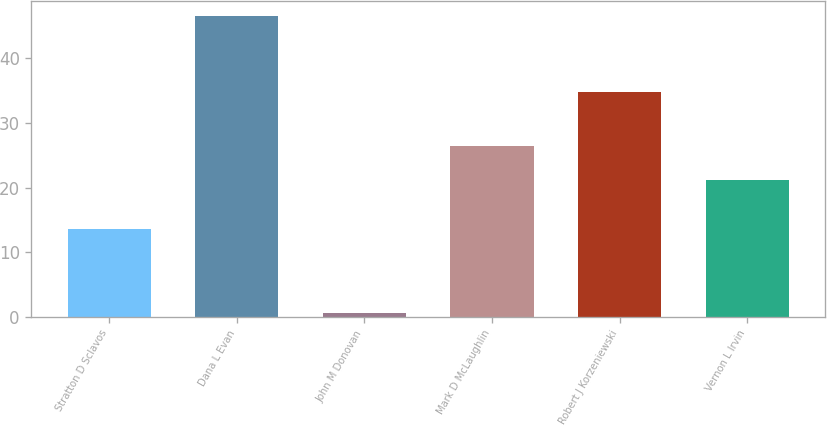Convert chart to OTSL. <chart><loc_0><loc_0><loc_500><loc_500><bar_chart><fcel>Stratton D Sclavos<fcel>Dana L Evan<fcel>John M Donovan<fcel>Mark D McLaughlin<fcel>Robert J Korzeniewski<fcel>Vernon L Irvin<nl><fcel>13.66<fcel>46.52<fcel>0.58<fcel>26.43<fcel>34.77<fcel>21.13<nl></chart> 